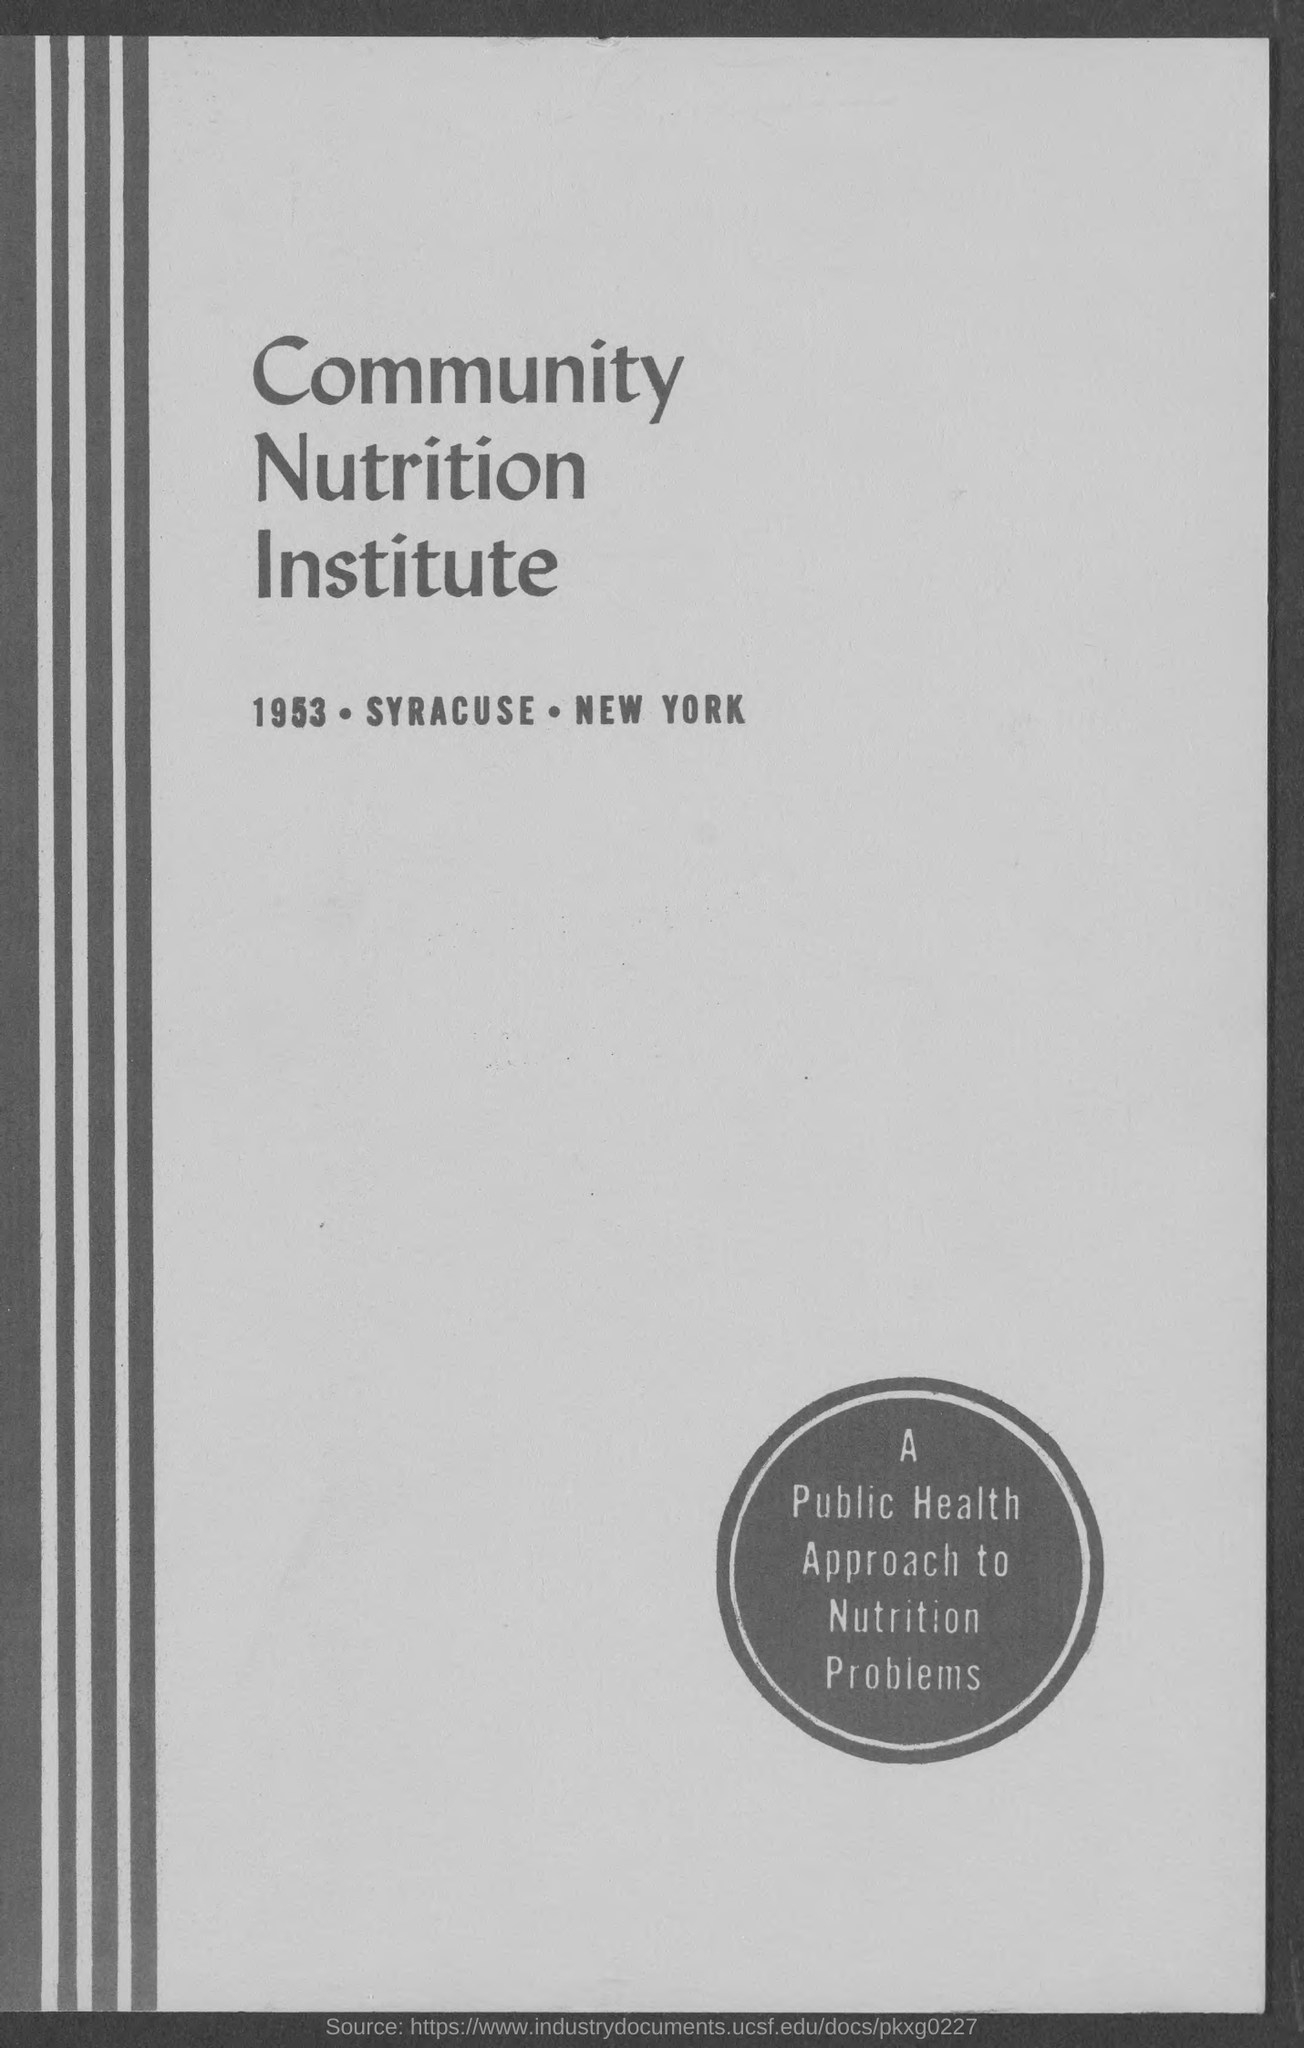Identify some key points in this picture. The Community Nutrition Institute is mentioned. The year mentioned is 1953. 